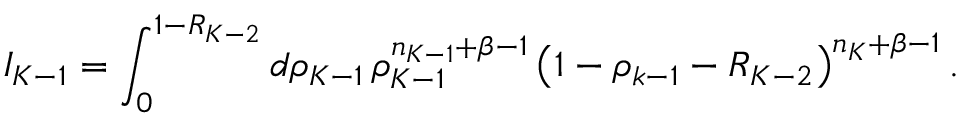Convert formula to latex. <formula><loc_0><loc_0><loc_500><loc_500>I _ { K - 1 } = \int _ { 0 } ^ { 1 - R _ { K - 2 } } d \rho _ { K - 1 } \, \rho _ { K - 1 } ^ { n _ { K - 1 } + \beta - 1 } \left ( 1 - \rho _ { k - 1 } - R _ { K - 2 } \right ) ^ { n _ { K } + \beta - 1 } .</formula> 